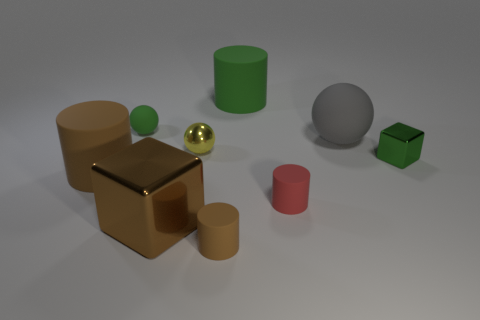Are there any rubber balls?
Ensure brevity in your answer.  Yes. How many brown cubes have the same size as the green rubber cylinder?
Your response must be concise. 1. How many tiny objects are in front of the big gray matte object and behind the green shiny cube?
Make the answer very short. 1. Does the cylinder behind the yellow object have the same size as the metal sphere?
Your answer should be very brief. No. Is there a big matte cylinder that has the same color as the tiny cube?
Provide a succinct answer. Yes. There is a gray sphere that is the same material as the tiny red cylinder; what size is it?
Keep it short and to the point. Large. Is the number of red matte cylinders behind the small red cylinder greater than the number of large rubber things in front of the green rubber sphere?
Ensure brevity in your answer.  No. What number of other objects are the same material as the small yellow object?
Your response must be concise. 2. Do the tiny green object that is behind the big gray matte thing and the small yellow ball have the same material?
Provide a short and direct response. No. What is the shape of the large green matte thing?
Your response must be concise. Cylinder. 